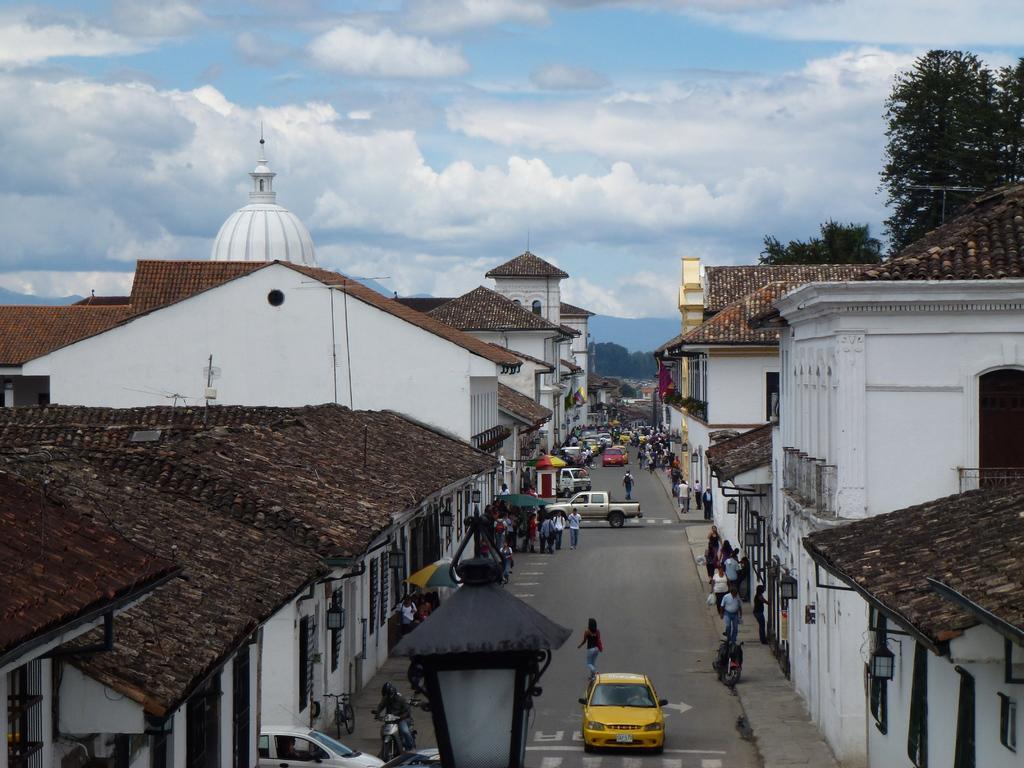Could you give a brief overview of what you see in this image? There are people and we can see vehicles on the road, lights and buildings. In the background we can see trees and sky with clouds. 